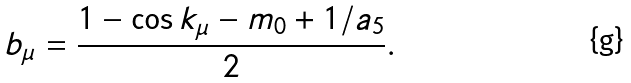<formula> <loc_0><loc_0><loc_500><loc_500>b _ { \mu } = \frac { 1 - \cos { k _ { \mu } } - m _ { 0 } + 1 / a _ { 5 } } { 2 } .</formula> 